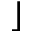Convert formula to latex. <formula><loc_0><loc_0><loc_500><loc_500>\rfloor</formula> 